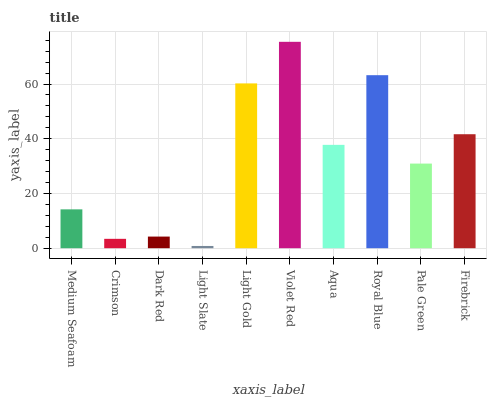Is Light Slate the minimum?
Answer yes or no. Yes. Is Violet Red the maximum?
Answer yes or no. Yes. Is Crimson the minimum?
Answer yes or no. No. Is Crimson the maximum?
Answer yes or no. No. Is Medium Seafoam greater than Crimson?
Answer yes or no. Yes. Is Crimson less than Medium Seafoam?
Answer yes or no. Yes. Is Crimson greater than Medium Seafoam?
Answer yes or no. No. Is Medium Seafoam less than Crimson?
Answer yes or no. No. Is Aqua the high median?
Answer yes or no. Yes. Is Pale Green the low median?
Answer yes or no. Yes. Is Violet Red the high median?
Answer yes or no. No. Is Dark Red the low median?
Answer yes or no. No. 